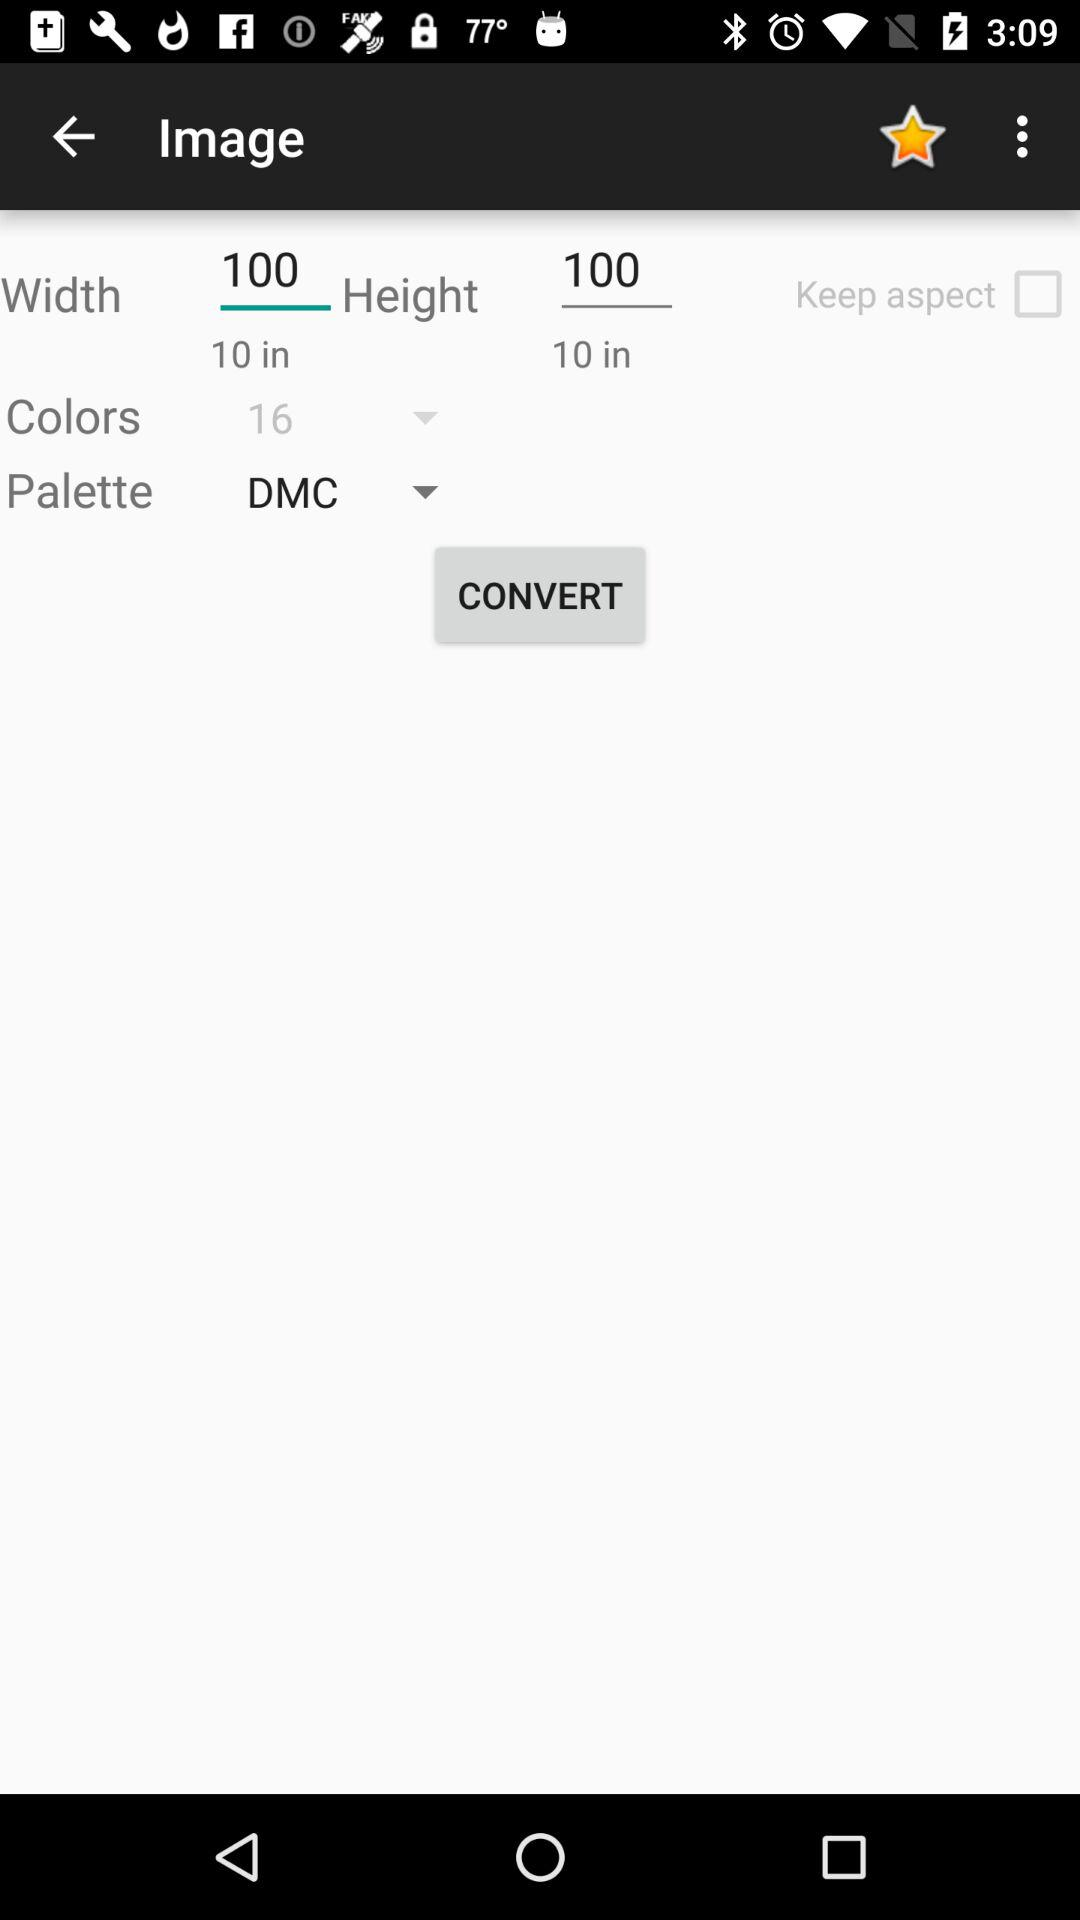Which option is selected for the palette? The selected option is "DMC". 